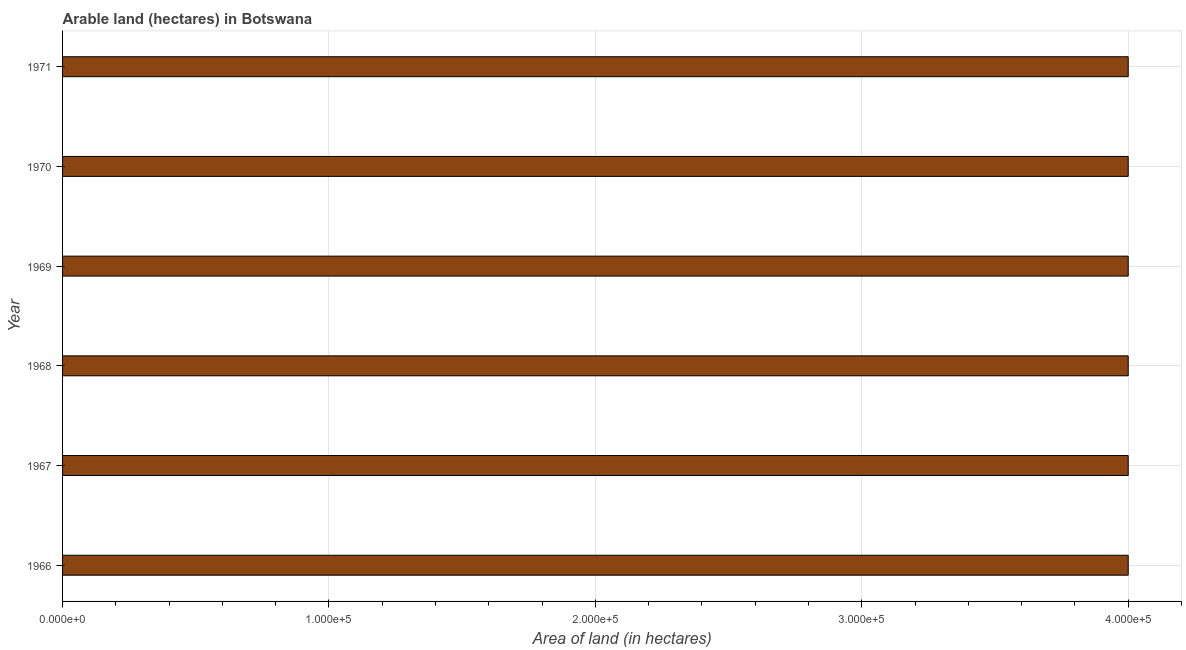Does the graph contain grids?
Ensure brevity in your answer.  Yes. What is the title of the graph?
Your response must be concise. Arable land (hectares) in Botswana. What is the label or title of the X-axis?
Give a very brief answer. Area of land (in hectares). What is the label or title of the Y-axis?
Your answer should be compact. Year. In which year was the area of land maximum?
Provide a short and direct response. 1966. In which year was the area of land minimum?
Your answer should be very brief. 1966. What is the sum of the area of land?
Your answer should be compact. 2.40e+06. What is the median area of land?
Keep it short and to the point. 4.00e+05. Do a majority of the years between 1966 and 1967 (inclusive) have area of land greater than 380000 hectares?
Give a very brief answer. Yes. Is the sum of the area of land in 1967 and 1968 greater than the maximum area of land across all years?
Your answer should be compact. Yes. What is the difference between the highest and the lowest area of land?
Keep it short and to the point. 0. In how many years, is the area of land greater than the average area of land taken over all years?
Keep it short and to the point. 0. How many bars are there?
Offer a very short reply. 6. Are all the bars in the graph horizontal?
Your response must be concise. Yes. How many years are there in the graph?
Offer a very short reply. 6. Are the values on the major ticks of X-axis written in scientific E-notation?
Provide a short and direct response. Yes. What is the Area of land (in hectares) of 1967?
Make the answer very short. 4.00e+05. What is the Area of land (in hectares) of 1971?
Offer a terse response. 4.00e+05. What is the difference between the Area of land (in hectares) in 1966 and 1968?
Provide a succinct answer. 0. What is the difference between the Area of land (in hectares) in 1966 and 1970?
Offer a very short reply. 0. What is the difference between the Area of land (in hectares) in 1966 and 1971?
Keep it short and to the point. 0. What is the difference between the Area of land (in hectares) in 1967 and 1970?
Keep it short and to the point. 0. What is the difference between the Area of land (in hectares) in 1968 and 1969?
Ensure brevity in your answer.  0. What is the difference between the Area of land (in hectares) in 1968 and 1971?
Ensure brevity in your answer.  0. What is the difference between the Area of land (in hectares) in 1969 and 1970?
Provide a succinct answer. 0. What is the difference between the Area of land (in hectares) in 1970 and 1971?
Give a very brief answer. 0. What is the ratio of the Area of land (in hectares) in 1966 to that in 1967?
Give a very brief answer. 1. What is the ratio of the Area of land (in hectares) in 1966 to that in 1968?
Your answer should be very brief. 1. What is the ratio of the Area of land (in hectares) in 1966 to that in 1971?
Offer a terse response. 1. What is the ratio of the Area of land (in hectares) in 1967 to that in 1971?
Ensure brevity in your answer.  1. What is the ratio of the Area of land (in hectares) in 1968 to that in 1969?
Your answer should be very brief. 1. What is the ratio of the Area of land (in hectares) in 1968 to that in 1970?
Provide a succinct answer. 1. What is the ratio of the Area of land (in hectares) in 1970 to that in 1971?
Ensure brevity in your answer.  1. 